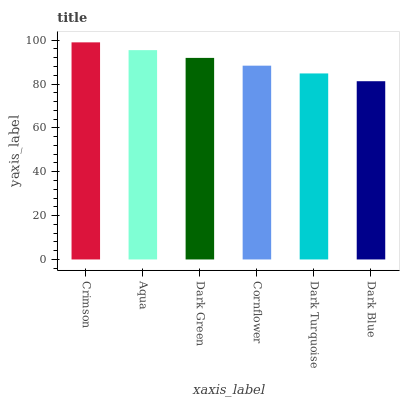Is Aqua the minimum?
Answer yes or no. No. Is Aqua the maximum?
Answer yes or no. No. Is Crimson greater than Aqua?
Answer yes or no. Yes. Is Aqua less than Crimson?
Answer yes or no. Yes. Is Aqua greater than Crimson?
Answer yes or no. No. Is Crimson less than Aqua?
Answer yes or no. No. Is Dark Green the high median?
Answer yes or no. Yes. Is Cornflower the low median?
Answer yes or no. Yes. Is Cornflower the high median?
Answer yes or no. No. Is Crimson the low median?
Answer yes or no. No. 